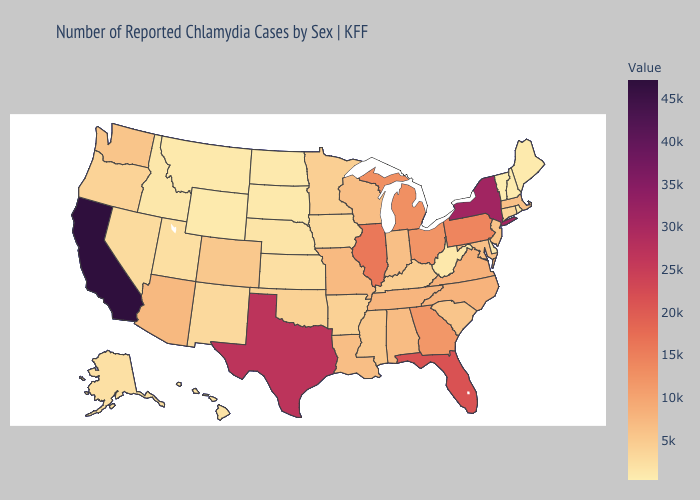Does Oregon have the lowest value in the West?
Be succinct. No. Which states have the highest value in the USA?
Short answer required. California. Among the states that border Connecticut , does Rhode Island have the lowest value?
Answer briefly. Yes. 